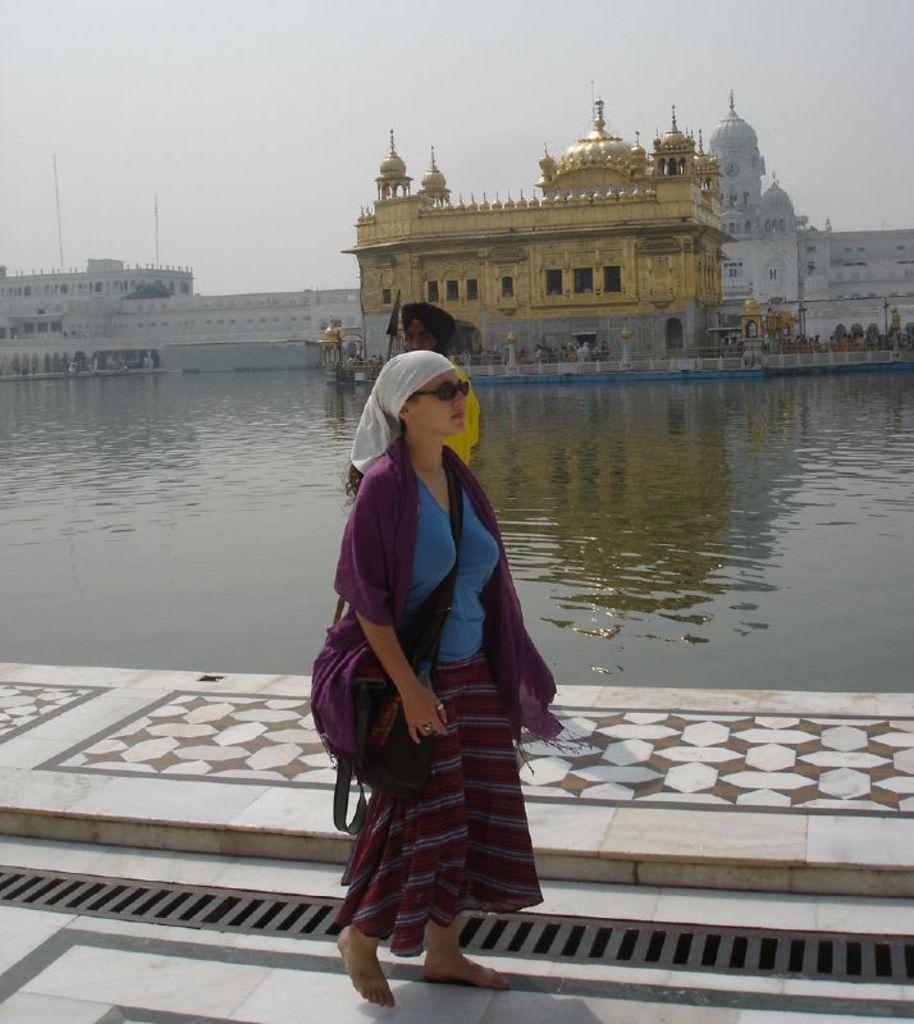What is the person in the image wearing? The person in the image is wearing a blue and purple dress. What can be seen in the image besides the person? There is water visible in the image, as well as many buildings. What is visible in the background of the image? The sky is visible in the background of the image. What type of toothbrush is the person using in the image? There is no toothbrush present in the image. 